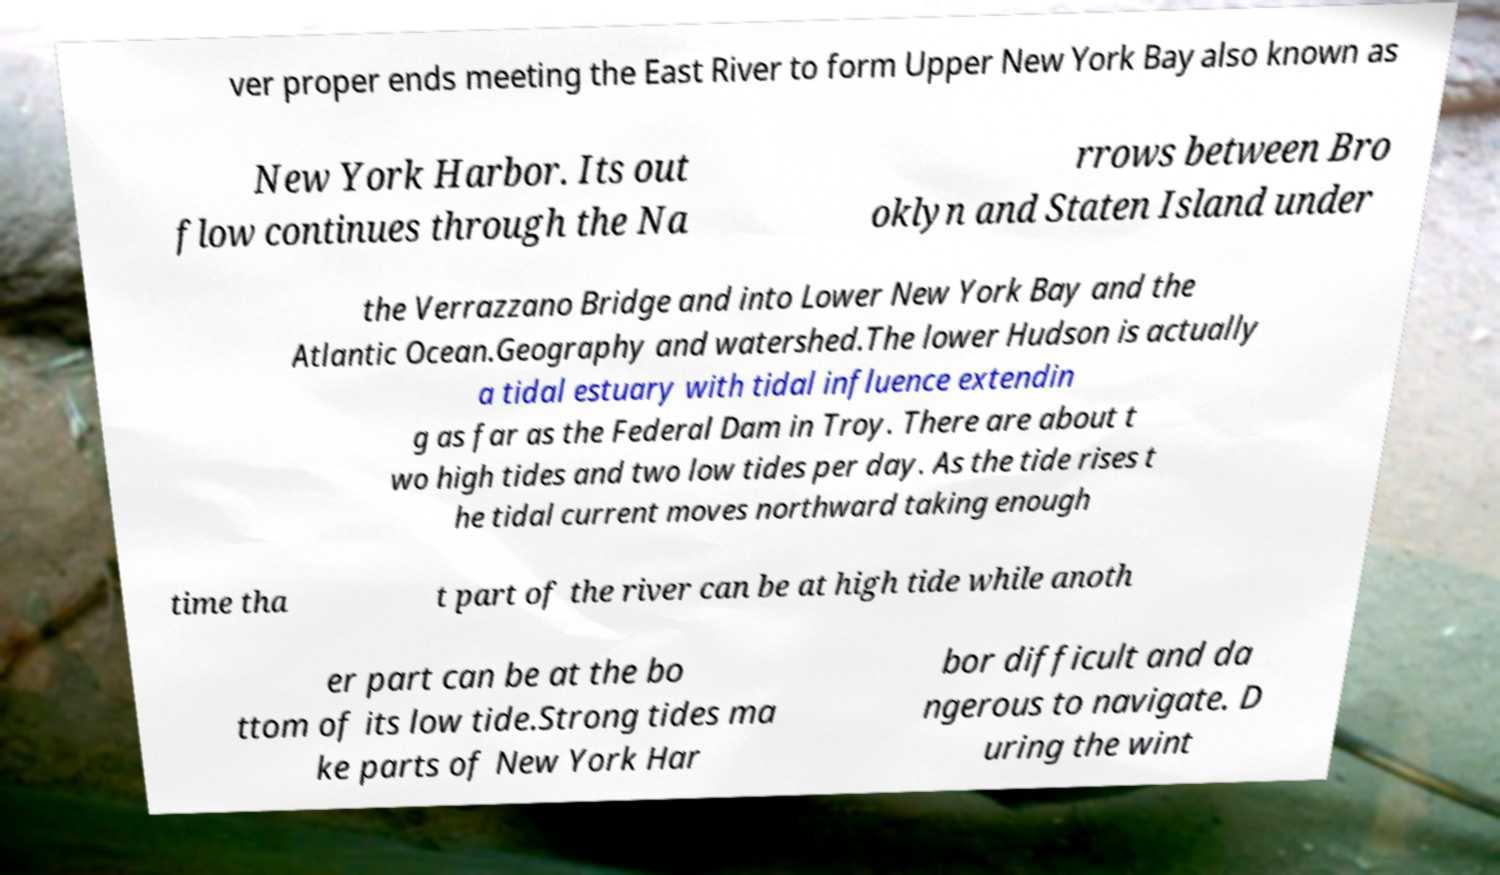What messages or text are displayed in this image? I need them in a readable, typed format. ver proper ends meeting the East River to form Upper New York Bay also known as New York Harbor. Its out flow continues through the Na rrows between Bro oklyn and Staten Island under the Verrazzano Bridge and into Lower New York Bay and the Atlantic Ocean.Geography and watershed.The lower Hudson is actually a tidal estuary with tidal influence extendin g as far as the Federal Dam in Troy. There are about t wo high tides and two low tides per day. As the tide rises t he tidal current moves northward taking enough time tha t part of the river can be at high tide while anoth er part can be at the bo ttom of its low tide.Strong tides ma ke parts of New York Har bor difficult and da ngerous to navigate. D uring the wint 